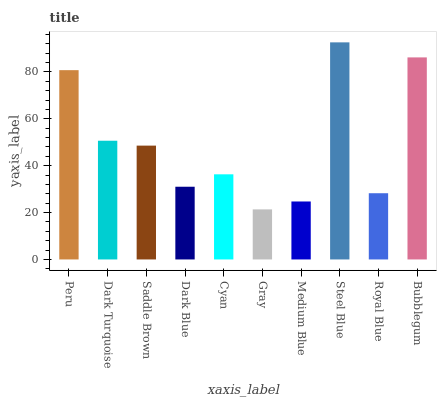Is Gray the minimum?
Answer yes or no. Yes. Is Steel Blue the maximum?
Answer yes or no. Yes. Is Dark Turquoise the minimum?
Answer yes or no. No. Is Dark Turquoise the maximum?
Answer yes or no. No. Is Peru greater than Dark Turquoise?
Answer yes or no. Yes. Is Dark Turquoise less than Peru?
Answer yes or no. Yes. Is Dark Turquoise greater than Peru?
Answer yes or no. No. Is Peru less than Dark Turquoise?
Answer yes or no. No. Is Saddle Brown the high median?
Answer yes or no. Yes. Is Cyan the low median?
Answer yes or no. Yes. Is Gray the high median?
Answer yes or no. No. Is Medium Blue the low median?
Answer yes or no. No. 